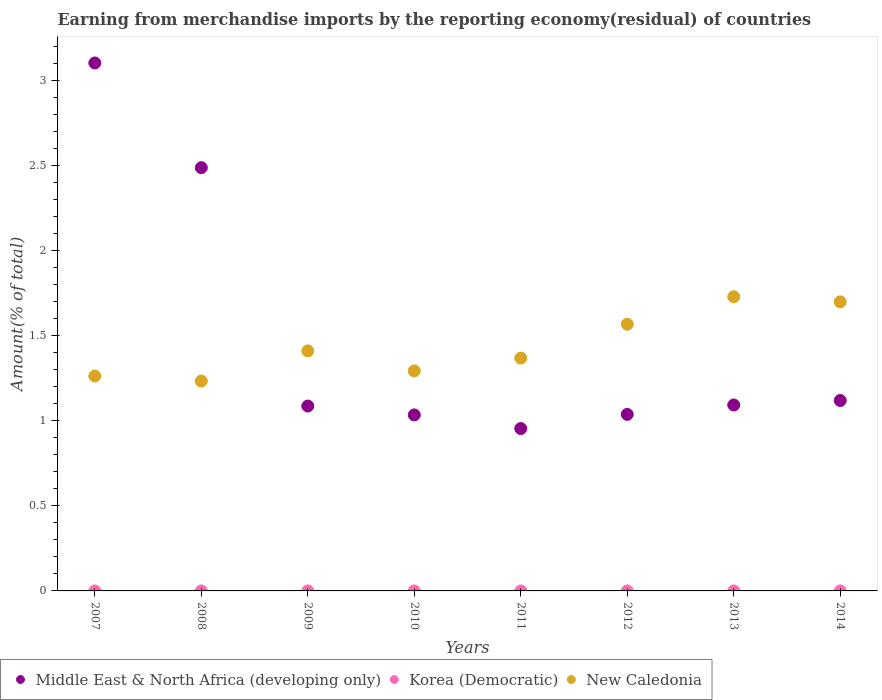Is the number of dotlines equal to the number of legend labels?
Provide a short and direct response. No. What is the percentage of amount earned from merchandise imports in Middle East & North Africa (developing only) in 2011?
Your answer should be compact. 0.95. Across all years, what is the maximum percentage of amount earned from merchandise imports in Middle East & North Africa (developing only)?
Your answer should be compact. 3.1. Across all years, what is the minimum percentage of amount earned from merchandise imports in Middle East & North Africa (developing only)?
Offer a terse response. 0.95. What is the total percentage of amount earned from merchandise imports in Middle East & North Africa (developing only) in the graph?
Your answer should be compact. 11.91. What is the difference between the percentage of amount earned from merchandise imports in New Caledonia in 2007 and that in 2010?
Ensure brevity in your answer.  -0.03. What is the difference between the percentage of amount earned from merchandise imports in New Caledonia in 2013 and the percentage of amount earned from merchandise imports in Korea (Democratic) in 2012?
Keep it short and to the point. 1.73. What is the average percentage of amount earned from merchandise imports in Korea (Democratic) per year?
Ensure brevity in your answer.  2.008655080248045e-9. In the year 2009, what is the difference between the percentage of amount earned from merchandise imports in New Caledonia and percentage of amount earned from merchandise imports in Korea (Democratic)?
Offer a very short reply. 1.41. What is the ratio of the percentage of amount earned from merchandise imports in New Caledonia in 2008 to that in 2010?
Keep it short and to the point. 0.95. Is the percentage of amount earned from merchandise imports in New Caledonia in 2007 less than that in 2014?
Offer a very short reply. Yes. Is the difference between the percentage of amount earned from merchandise imports in New Caledonia in 2011 and 2013 greater than the difference between the percentage of amount earned from merchandise imports in Korea (Democratic) in 2011 and 2013?
Ensure brevity in your answer.  No. What is the difference between the highest and the second highest percentage of amount earned from merchandise imports in New Caledonia?
Offer a very short reply. 0.03. What is the difference between the highest and the lowest percentage of amount earned from merchandise imports in Middle East & North Africa (developing only)?
Provide a succinct answer. 2.15. Is the sum of the percentage of amount earned from merchandise imports in Middle East & North Africa (developing only) in 2008 and 2010 greater than the maximum percentage of amount earned from merchandise imports in Korea (Democratic) across all years?
Provide a short and direct response. Yes. Does the percentage of amount earned from merchandise imports in New Caledonia monotonically increase over the years?
Ensure brevity in your answer.  No. What is the difference between two consecutive major ticks on the Y-axis?
Offer a very short reply. 0.5. Are the values on the major ticks of Y-axis written in scientific E-notation?
Offer a very short reply. No. Does the graph contain any zero values?
Offer a very short reply. Yes. Does the graph contain grids?
Give a very brief answer. No. Where does the legend appear in the graph?
Keep it short and to the point. Bottom left. How are the legend labels stacked?
Offer a terse response. Horizontal. What is the title of the graph?
Make the answer very short. Earning from merchandise imports by the reporting economy(residual) of countries. Does "Hong Kong" appear as one of the legend labels in the graph?
Make the answer very short. No. What is the label or title of the X-axis?
Make the answer very short. Years. What is the label or title of the Y-axis?
Give a very brief answer. Amount(% of total). What is the Amount(% of total) of Middle East & North Africa (developing only) in 2007?
Your answer should be very brief. 3.1. What is the Amount(% of total) in New Caledonia in 2007?
Provide a short and direct response. 1.26. What is the Amount(% of total) in Middle East & North Africa (developing only) in 2008?
Give a very brief answer. 2.49. What is the Amount(% of total) in Korea (Democratic) in 2008?
Ensure brevity in your answer.  0. What is the Amount(% of total) of New Caledonia in 2008?
Give a very brief answer. 1.23. What is the Amount(% of total) of Middle East & North Africa (developing only) in 2009?
Keep it short and to the point. 1.09. What is the Amount(% of total) of Korea (Democratic) in 2009?
Ensure brevity in your answer.  1.52340312053516e-9. What is the Amount(% of total) of New Caledonia in 2009?
Provide a succinct answer. 1.41. What is the Amount(% of total) in Middle East & North Africa (developing only) in 2010?
Your answer should be very brief. 1.03. What is the Amount(% of total) in New Caledonia in 2010?
Make the answer very short. 1.29. What is the Amount(% of total) in Middle East & North Africa (developing only) in 2011?
Keep it short and to the point. 0.95. What is the Amount(% of total) of Korea (Democratic) in 2011?
Provide a succinct answer. 5.979273196495129e-9. What is the Amount(% of total) of New Caledonia in 2011?
Make the answer very short. 1.37. What is the Amount(% of total) of Middle East & North Africa (developing only) in 2012?
Offer a very short reply. 1.04. What is the Amount(% of total) of Korea (Democratic) in 2012?
Give a very brief answer. 3.666766615126721e-9. What is the Amount(% of total) of New Caledonia in 2012?
Make the answer very short. 1.57. What is the Amount(% of total) in Middle East & North Africa (developing only) in 2013?
Provide a short and direct response. 1.09. What is the Amount(% of total) in Korea (Democratic) in 2013?
Your response must be concise. 4.89979770982735e-9. What is the Amount(% of total) of New Caledonia in 2013?
Keep it short and to the point. 1.73. What is the Amount(% of total) of Middle East & North Africa (developing only) in 2014?
Offer a very short reply. 1.12. What is the Amount(% of total) of New Caledonia in 2014?
Your response must be concise. 1.7. Across all years, what is the maximum Amount(% of total) in Middle East & North Africa (developing only)?
Your response must be concise. 3.1. Across all years, what is the maximum Amount(% of total) in Korea (Democratic)?
Provide a succinct answer. 5.979273196495129e-9. Across all years, what is the maximum Amount(% of total) of New Caledonia?
Offer a terse response. 1.73. Across all years, what is the minimum Amount(% of total) in Middle East & North Africa (developing only)?
Offer a very short reply. 0.95. Across all years, what is the minimum Amount(% of total) in New Caledonia?
Your response must be concise. 1.23. What is the total Amount(% of total) in Middle East & North Africa (developing only) in the graph?
Keep it short and to the point. 11.91. What is the total Amount(% of total) in Korea (Democratic) in the graph?
Your answer should be compact. 0. What is the total Amount(% of total) in New Caledonia in the graph?
Your answer should be very brief. 11.56. What is the difference between the Amount(% of total) of Middle East & North Africa (developing only) in 2007 and that in 2008?
Make the answer very short. 0.62. What is the difference between the Amount(% of total) in New Caledonia in 2007 and that in 2008?
Ensure brevity in your answer.  0.03. What is the difference between the Amount(% of total) in Middle East & North Africa (developing only) in 2007 and that in 2009?
Offer a terse response. 2.02. What is the difference between the Amount(% of total) of New Caledonia in 2007 and that in 2009?
Ensure brevity in your answer.  -0.15. What is the difference between the Amount(% of total) in Middle East & North Africa (developing only) in 2007 and that in 2010?
Give a very brief answer. 2.07. What is the difference between the Amount(% of total) of New Caledonia in 2007 and that in 2010?
Provide a short and direct response. -0.03. What is the difference between the Amount(% of total) of Middle East & North Africa (developing only) in 2007 and that in 2011?
Provide a succinct answer. 2.15. What is the difference between the Amount(% of total) in New Caledonia in 2007 and that in 2011?
Provide a short and direct response. -0.11. What is the difference between the Amount(% of total) in Middle East & North Africa (developing only) in 2007 and that in 2012?
Your answer should be very brief. 2.06. What is the difference between the Amount(% of total) in New Caledonia in 2007 and that in 2012?
Give a very brief answer. -0.3. What is the difference between the Amount(% of total) of Middle East & North Africa (developing only) in 2007 and that in 2013?
Provide a short and direct response. 2.01. What is the difference between the Amount(% of total) of New Caledonia in 2007 and that in 2013?
Ensure brevity in your answer.  -0.47. What is the difference between the Amount(% of total) in Middle East & North Africa (developing only) in 2007 and that in 2014?
Your answer should be compact. 1.98. What is the difference between the Amount(% of total) of New Caledonia in 2007 and that in 2014?
Provide a short and direct response. -0.44. What is the difference between the Amount(% of total) in Middle East & North Africa (developing only) in 2008 and that in 2009?
Provide a succinct answer. 1.4. What is the difference between the Amount(% of total) in New Caledonia in 2008 and that in 2009?
Offer a terse response. -0.18. What is the difference between the Amount(% of total) of Middle East & North Africa (developing only) in 2008 and that in 2010?
Offer a very short reply. 1.45. What is the difference between the Amount(% of total) in New Caledonia in 2008 and that in 2010?
Your answer should be compact. -0.06. What is the difference between the Amount(% of total) in Middle East & North Africa (developing only) in 2008 and that in 2011?
Your response must be concise. 1.53. What is the difference between the Amount(% of total) of New Caledonia in 2008 and that in 2011?
Your answer should be compact. -0.13. What is the difference between the Amount(% of total) of Middle East & North Africa (developing only) in 2008 and that in 2012?
Give a very brief answer. 1.45. What is the difference between the Amount(% of total) of New Caledonia in 2008 and that in 2012?
Provide a succinct answer. -0.33. What is the difference between the Amount(% of total) of Middle East & North Africa (developing only) in 2008 and that in 2013?
Offer a very short reply. 1.39. What is the difference between the Amount(% of total) of New Caledonia in 2008 and that in 2013?
Keep it short and to the point. -0.5. What is the difference between the Amount(% of total) of Middle East & North Africa (developing only) in 2008 and that in 2014?
Give a very brief answer. 1.37. What is the difference between the Amount(% of total) in New Caledonia in 2008 and that in 2014?
Keep it short and to the point. -0.47. What is the difference between the Amount(% of total) of Middle East & North Africa (developing only) in 2009 and that in 2010?
Offer a very short reply. 0.05. What is the difference between the Amount(% of total) of New Caledonia in 2009 and that in 2010?
Offer a very short reply. 0.12. What is the difference between the Amount(% of total) of Middle East & North Africa (developing only) in 2009 and that in 2011?
Provide a short and direct response. 0.13. What is the difference between the Amount(% of total) in Korea (Democratic) in 2009 and that in 2011?
Offer a very short reply. -0. What is the difference between the Amount(% of total) of New Caledonia in 2009 and that in 2011?
Provide a succinct answer. 0.04. What is the difference between the Amount(% of total) in Middle East & North Africa (developing only) in 2009 and that in 2012?
Offer a very short reply. 0.05. What is the difference between the Amount(% of total) of Korea (Democratic) in 2009 and that in 2012?
Your answer should be compact. -0. What is the difference between the Amount(% of total) in New Caledonia in 2009 and that in 2012?
Your answer should be compact. -0.16. What is the difference between the Amount(% of total) in Middle East & North Africa (developing only) in 2009 and that in 2013?
Keep it short and to the point. -0.01. What is the difference between the Amount(% of total) of New Caledonia in 2009 and that in 2013?
Ensure brevity in your answer.  -0.32. What is the difference between the Amount(% of total) in Middle East & North Africa (developing only) in 2009 and that in 2014?
Give a very brief answer. -0.03. What is the difference between the Amount(% of total) of New Caledonia in 2009 and that in 2014?
Provide a succinct answer. -0.29. What is the difference between the Amount(% of total) in Middle East & North Africa (developing only) in 2010 and that in 2011?
Provide a short and direct response. 0.08. What is the difference between the Amount(% of total) in New Caledonia in 2010 and that in 2011?
Provide a succinct answer. -0.08. What is the difference between the Amount(% of total) of Middle East & North Africa (developing only) in 2010 and that in 2012?
Provide a short and direct response. -0. What is the difference between the Amount(% of total) in New Caledonia in 2010 and that in 2012?
Ensure brevity in your answer.  -0.27. What is the difference between the Amount(% of total) of Middle East & North Africa (developing only) in 2010 and that in 2013?
Your answer should be very brief. -0.06. What is the difference between the Amount(% of total) of New Caledonia in 2010 and that in 2013?
Your answer should be very brief. -0.44. What is the difference between the Amount(% of total) of Middle East & North Africa (developing only) in 2010 and that in 2014?
Provide a short and direct response. -0.08. What is the difference between the Amount(% of total) of New Caledonia in 2010 and that in 2014?
Offer a terse response. -0.41. What is the difference between the Amount(% of total) of Middle East & North Africa (developing only) in 2011 and that in 2012?
Make the answer very short. -0.08. What is the difference between the Amount(% of total) of New Caledonia in 2011 and that in 2012?
Provide a succinct answer. -0.2. What is the difference between the Amount(% of total) in Middle East & North Africa (developing only) in 2011 and that in 2013?
Offer a terse response. -0.14. What is the difference between the Amount(% of total) in New Caledonia in 2011 and that in 2013?
Give a very brief answer. -0.36. What is the difference between the Amount(% of total) of Middle East & North Africa (developing only) in 2011 and that in 2014?
Your response must be concise. -0.16. What is the difference between the Amount(% of total) of New Caledonia in 2011 and that in 2014?
Ensure brevity in your answer.  -0.33. What is the difference between the Amount(% of total) in Middle East & North Africa (developing only) in 2012 and that in 2013?
Keep it short and to the point. -0.06. What is the difference between the Amount(% of total) in Korea (Democratic) in 2012 and that in 2013?
Your response must be concise. -0. What is the difference between the Amount(% of total) in New Caledonia in 2012 and that in 2013?
Provide a succinct answer. -0.16. What is the difference between the Amount(% of total) in Middle East & North Africa (developing only) in 2012 and that in 2014?
Keep it short and to the point. -0.08. What is the difference between the Amount(% of total) in New Caledonia in 2012 and that in 2014?
Keep it short and to the point. -0.13. What is the difference between the Amount(% of total) of Middle East & North Africa (developing only) in 2013 and that in 2014?
Make the answer very short. -0.03. What is the difference between the Amount(% of total) of New Caledonia in 2013 and that in 2014?
Make the answer very short. 0.03. What is the difference between the Amount(% of total) in Middle East & North Africa (developing only) in 2007 and the Amount(% of total) in New Caledonia in 2008?
Make the answer very short. 1.87. What is the difference between the Amount(% of total) in Middle East & North Africa (developing only) in 2007 and the Amount(% of total) in Korea (Democratic) in 2009?
Offer a terse response. 3.1. What is the difference between the Amount(% of total) in Middle East & North Africa (developing only) in 2007 and the Amount(% of total) in New Caledonia in 2009?
Keep it short and to the point. 1.69. What is the difference between the Amount(% of total) of Middle East & North Africa (developing only) in 2007 and the Amount(% of total) of New Caledonia in 2010?
Offer a very short reply. 1.81. What is the difference between the Amount(% of total) in Middle East & North Africa (developing only) in 2007 and the Amount(% of total) in Korea (Democratic) in 2011?
Offer a terse response. 3.1. What is the difference between the Amount(% of total) in Middle East & North Africa (developing only) in 2007 and the Amount(% of total) in New Caledonia in 2011?
Provide a succinct answer. 1.73. What is the difference between the Amount(% of total) of Middle East & North Africa (developing only) in 2007 and the Amount(% of total) of Korea (Democratic) in 2012?
Make the answer very short. 3.1. What is the difference between the Amount(% of total) of Middle East & North Africa (developing only) in 2007 and the Amount(% of total) of New Caledonia in 2012?
Make the answer very short. 1.54. What is the difference between the Amount(% of total) in Middle East & North Africa (developing only) in 2007 and the Amount(% of total) in Korea (Democratic) in 2013?
Your answer should be compact. 3.1. What is the difference between the Amount(% of total) of Middle East & North Africa (developing only) in 2007 and the Amount(% of total) of New Caledonia in 2013?
Your response must be concise. 1.37. What is the difference between the Amount(% of total) in Middle East & North Africa (developing only) in 2007 and the Amount(% of total) in New Caledonia in 2014?
Offer a very short reply. 1.4. What is the difference between the Amount(% of total) of Middle East & North Africa (developing only) in 2008 and the Amount(% of total) of Korea (Democratic) in 2009?
Ensure brevity in your answer.  2.49. What is the difference between the Amount(% of total) of Middle East & North Africa (developing only) in 2008 and the Amount(% of total) of New Caledonia in 2009?
Provide a short and direct response. 1.08. What is the difference between the Amount(% of total) of Middle East & North Africa (developing only) in 2008 and the Amount(% of total) of New Caledonia in 2010?
Give a very brief answer. 1.19. What is the difference between the Amount(% of total) of Middle East & North Africa (developing only) in 2008 and the Amount(% of total) of Korea (Democratic) in 2011?
Provide a short and direct response. 2.49. What is the difference between the Amount(% of total) of Middle East & North Africa (developing only) in 2008 and the Amount(% of total) of New Caledonia in 2011?
Ensure brevity in your answer.  1.12. What is the difference between the Amount(% of total) in Middle East & North Africa (developing only) in 2008 and the Amount(% of total) in Korea (Democratic) in 2012?
Provide a short and direct response. 2.49. What is the difference between the Amount(% of total) in Middle East & North Africa (developing only) in 2008 and the Amount(% of total) in New Caledonia in 2012?
Provide a succinct answer. 0.92. What is the difference between the Amount(% of total) in Middle East & North Africa (developing only) in 2008 and the Amount(% of total) in Korea (Democratic) in 2013?
Provide a succinct answer. 2.49. What is the difference between the Amount(% of total) in Middle East & North Africa (developing only) in 2008 and the Amount(% of total) in New Caledonia in 2013?
Make the answer very short. 0.76. What is the difference between the Amount(% of total) of Middle East & North Africa (developing only) in 2008 and the Amount(% of total) of New Caledonia in 2014?
Make the answer very short. 0.79. What is the difference between the Amount(% of total) of Middle East & North Africa (developing only) in 2009 and the Amount(% of total) of New Caledonia in 2010?
Offer a terse response. -0.21. What is the difference between the Amount(% of total) in Korea (Democratic) in 2009 and the Amount(% of total) in New Caledonia in 2010?
Offer a very short reply. -1.29. What is the difference between the Amount(% of total) of Middle East & North Africa (developing only) in 2009 and the Amount(% of total) of Korea (Democratic) in 2011?
Make the answer very short. 1.09. What is the difference between the Amount(% of total) of Middle East & North Africa (developing only) in 2009 and the Amount(% of total) of New Caledonia in 2011?
Keep it short and to the point. -0.28. What is the difference between the Amount(% of total) of Korea (Democratic) in 2009 and the Amount(% of total) of New Caledonia in 2011?
Provide a short and direct response. -1.37. What is the difference between the Amount(% of total) in Middle East & North Africa (developing only) in 2009 and the Amount(% of total) in Korea (Democratic) in 2012?
Offer a terse response. 1.09. What is the difference between the Amount(% of total) of Middle East & North Africa (developing only) in 2009 and the Amount(% of total) of New Caledonia in 2012?
Offer a terse response. -0.48. What is the difference between the Amount(% of total) of Korea (Democratic) in 2009 and the Amount(% of total) of New Caledonia in 2012?
Make the answer very short. -1.57. What is the difference between the Amount(% of total) of Middle East & North Africa (developing only) in 2009 and the Amount(% of total) of Korea (Democratic) in 2013?
Provide a succinct answer. 1.09. What is the difference between the Amount(% of total) of Middle East & North Africa (developing only) in 2009 and the Amount(% of total) of New Caledonia in 2013?
Make the answer very short. -0.64. What is the difference between the Amount(% of total) of Korea (Democratic) in 2009 and the Amount(% of total) of New Caledonia in 2013?
Provide a succinct answer. -1.73. What is the difference between the Amount(% of total) of Middle East & North Africa (developing only) in 2009 and the Amount(% of total) of New Caledonia in 2014?
Offer a very short reply. -0.61. What is the difference between the Amount(% of total) in Korea (Democratic) in 2009 and the Amount(% of total) in New Caledonia in 2014?
Offer a terse response. -1.7. What is the difference between the Amount(% of total) of Middle East & North Africa (developing only) in 2010 and the Amount(% of total) of Korea (Democratic) in 2011?
Offer a terse response. 1.03. What is the difference between the Amount(% of total) of Middle East & North Africa (developing only) in 2010 and the Amount(% of total) of New Caledonia in 2011?
Keep it short and to the point. -0.33. What is the difference between the Amount(% of total) in Middle East & North Africa (developing only) in 2010 and the Amount(% of total) in Korea (Democratic) in 2012?
Ensure brevity in your answer.  1.03. What is the difference between the Amount(% of total) in Middle East & North Africa (developing only) in 2010 and the Amount(% of total) in New Caledonia in 2012?
Ensure brevity in your answer.  -0.53. What is the difference between the Amount(% of total) in Middle East & North Africa (developing only) in 2010 and the Amount(% of total) in Korea (Democratic) in 2013?
Offer a very short reply. 1.03. What is the difference between the Amount(% of total) in Middle East & North Africa (developing only) in 2010 and the Amount(% of total) in New Caledonia in 2013?
Provide a short and direct response. -0.69. What is the difference between the Amount(% of total) in Middle East & North Africa (developing only) in 2010 and the Amount(% of total) in New Caledonia in 2014?
Keep it short and to the point. -0.66. What is the difference between the Amount(% of total) of Middle East & North Africa (developing only) in 2011 and the Amount(% of total) of Korea (Democratic) in 2012?
Give a very brief answer. 0.95. What is the difference between the Amount(% of total) of Middle East & North Africa (developing only) in 2011 and the Amount(% of total) of New Caledonia in 2012?
Keep it short and to the point. -0.61. What is the difference between the Amount(% of total) in Korea (Democratic) in 2011 and the Amount(% of total) in New Caledonia in 2012?
Provide a succinct answer. -1.57. What is the difference between the Amount(% of total) of Middle East & North Africa (developing only) in 2011 and the Amount(% of total) of Korea (Democratic) in 2013?
Ensure brevity in your answer.  0.95. What is the difference between the Amount(% of total) in Middle East & North Africa (developing only) in 2011 and the Amount(% of total) in New Caledonia in 2013?
Offer a very short reply. -0.77. What is the difference between the Amount(% of total) of Korea (Democratic) in 2011 and the Amount(% of total) of New Caledonia in 2013?
Make the answer very short. -1.73. What is the difference between the Amount(% of total) in Middle East & North Africa (developing only) in 2011 and the Amount(% of total) in New Caledonia in 2014?
Make the answer very short. -0.74. What is the difference between the Amount(% of total) in Korea (Democratic) in 2011 and the Amount(% of total) in New Caledonia in 2014?
Your response must be concise. -1.7. What is the difference between the Amount(% of total) of Middle East & North Africa (developing only) in 2012 and the Amount(% of total) of Korea (Democratic) in 2013?
Your answer should be compact. 1.04. What is the difference between the Amount(% of total) of Middle East & North Africa (developing only) in 2012 and the Amount(% of total) of New Caledonia in 2013?
Make the answer very short. -0.69. What is the difference between the Amount(% of total) in Korea (Democratic) in 2012 and the Amount(% of total) in New Caledonia in 2013?
Your response must be concise. -1.73. What is the difference between the Amount(% of total) of Middle East & North Africa (developing only) in 2012 and the Amount(% of total) of New Caledonia in 2014?
Offer a terse response. -0.66. What is the difference between the Amount(% of total) in Korea (Democratic) in 2012 and the Amount(% of total) in New Caledonia in 2014?
Provide a succinct answer. -1.7. What is the difference between the Amount(% of total) in Middle East & North Africa (developing only) in 2013 and the Amount(% of total) in New Caledonia in 2014?
Give a very brief answer. -0.61. What is the difference between the Amount(% of total) in Korea (Democratic) in 2013 and the Amount(% of total) in New Caledonia in 2014?
Provide a short and direct response. -1.7. What is the average Amount(% of total) of Middle East & North Africa (developing only) per year?
Provide a short and direct response. 1.49. What is the average Amount(% of total) of Korea (Democratic) per year?
Offer a terse response. 0. What is the average Amount(% of total) in New Caledonia per year?
Your answer should be compact. 1.45. In the year 2007, what is the difference between the Amount(% of total) in Middle East & North Africa (developing only) and Amount(% of total) in New Caledonia?
Provide a short and direct response. 1.84. In the year 2008, what is the difference between the Amount(% of total) of Middle East & North Africa (developing only) and Amount(% of total) of New Caledonia?
Provide a succinct answer. 1.25. In the year 2009, what is the difference between the Amount(% of total) in Middle East & North Africa (developing only) and Amount(% of total) in Korea (Democratic)?
Your answer should be very brief. 1.09. In the year 2009, what is the difference between the Amount(% of total) in Middle East & North Africa (developing only) and Amount(% of total) in New Caledonia?
Ensure brevity in your answer.  -0.32. In the year 2009, what is the difference between the Amount(% of total) of Korea (Democratic) and Amount(% of total) of New Caledonia?
Offer a very short reply. -1.41. In the year 2010, what is the difference between the Amount(% of total) in Middle East & North Africa (developing only) and Amount(% of total) in New Caledonia?
Your response must be concise. -0.26. In the year 2011, what is the difference between the Amount(% of total) in Middle East & North Africa (developing only) and Amount(% of total) in Korea (Democratic)?
Your answer should be very brief. 0.95. In the year 2011, what is the difference between the Amount(% of total) in Middle East & North Africa (developing only) and Amount(% of total) in New Caledonia?
Your answer should be very brief. -0.41. In the year 2011, what is the difference between the Amount(% of total) of Korea (Democratic) and Amount(% of total) of New Caledonia?
Keep it short and to the point. -1.37. In the year 2012, what is the difference between the Amount(% of total) of Middle East & North Africa (developing only) and Amount(% of total) of Korea (Democratic)?
Offer a very short reply. 1.04. In the year 2012, what is the difference between the Amount(% of total) in Middle East & North Africa (developing only) and Amount(% of total) in New Caledonia?
Your answer should be compact. -0.53. In the year 2012, what is the difference between the Amount(% of total) in Korea (Democratic) and Amount(% of total) in New Caledonia?
Make the answer very short. -1.57. In the year 2013, what is the difference between the Amount(% of total) in Middle East & North Africa (developing only) and Amount(% of total) in Korea (Democratic)?
Provide a short and direct response. 1.09. In the year 2013, what is the difference between the Amount(% of total) in Middle East & North Africa (developing only) and Amount(% of total) in New Caledonia?
Offer a terse response. -0.64. In the year 2013, what is the difference between the Amount(% of total) of Korea (Democratic) and Amount(% of total) of New Caledonia?
Provide a succinct answer. -1.73. In the year 2014, what is the difference between the Amount(% of total) in Middle East & North Africa (developing only) and Amount(% of total) in New Caledonia?
Keep it short and to the point. -0.58. What is the ratio of the Amount(% of total) of Middle East & North Africa (developing only) in 2007 to that in 2008?
Keep it short and to the point. 1.25. What is the ratio of the Amount(% of total) of New Caledonia in 2007 to that in 2008?
Keep it short and to the point. 1.02. What is the ratio of the Amount(% of total) in Middle East & North Africa (developing only) in 2007 to that in 2009?
Make the answer very short. 2.86. What is the ratio of the Amount(% of total) in New Caledonia in 2007 to that in 2009?
Your answer should be very brief. 0.9. What is the ratio of the Amount(% of total) of Middle East & North Africa (developing only) in 2007 to that in 2010?
Your answer should be compact. 3. What is the ratio of the Amount(% of total) of New Caledonia in 2007 to that in 2010?
Your answer should be very brief. 0.98. What is the ratio of the Amount(% of total) of Middle East & North Africa (developing only) in 2007 to that in 2011?
Your response must be concise. 3.25. What is the ratio of the Amount(% of total) of New Caledonia in 2007 to that in 2011?
Offer a terse response. 0.92. What is the ratio of the Amount(% of total) in Middle East & North Africa (developing only) in 2007 to that in 2012?
Keep it short and to the point. 2.99. What is the ratio of the Amount(% of total) of New Caledonia in 2007 to that in 2012?
Give a very brief answer. 0.81. What is the ratio of the Amount(% of total) in Middle East & North Africa (developing only) in 2007 to that in 2013?
Make the answer very short. 2.84. What is the ratio of the Amount(% of total) in New Caledonia in 2007 to that in 2013?
Give a very brief answer. 0.73. What is the ratio of the Amount(% of total) in Middle East & North Africa (developing only) in 2007 to that in 2014?
Provide a short and direct response. 2.77. What is the ratio of the Amount(% of total) in New Caledonia in 2007 to that in 2014?
Give a very brief answer. 0.74. What is the ratio of the Amount(% of total) in Middle East & North Africa (developing only) in 2008 to that in 2009?
Give a very brief answer. 2.29. What is the ratio of the Amount(% of total) in New Caledonia in 2008 to that in 2009?
Offer a very short reply. 0.87. What is the ratio of the Amount(% of total) of Middle East & North Africa (developing only) in 2008 to that in 2010?
Your answer should be compact. 2.4. What is the ratio of the Amount(% of total) in New Caledonia in 2008 to that in 2010?
Your answer should be compact. 0.95. What is the ratio of the Amount(% of total) of Middle East & North Africa (developing only) in 2008 to that in 2011?
Offer a terse response. 2.61. What is the ratio of the Amount(% of total) in New Caledonia in 2008 to that in 2011?
Your answer should be very brief. 0.9. What is the ratio of the Amount(% of total) in Middle East & North Africa (developing only) in 2008 to that in 2012?
Keep it short and to the point. 2.4. What is the ratio of the Amount(% of total) in New Caledonia in 2008 to that in 2012?
Your response must be concise. 0.79. What is the ratio of the Amount(% of total) of Middle East & North Africa (developing only) in 2008 to that in 2013?
Keep it short and to the point. 2.28. What is the ratio of the Amount(% of total) in New Caledonia in 2008 to that in 2013?
Provide a succinct answer. 0.71. What is the ratio of the Amount(% of total) of Middle East & North Africa (developing only) in 2008 to that in 2014?
Provide a succinct answer. 2.22. What is the ratio of the Amount(% of total) of New Caledonia in 2008 to that in 2014?
Provide a short and direct response. 0.73. What is the ratio of the Amount(% of total) in Middle East & North Africa (developing only) in 2009 to that in 2010?
Keep it short and to the point. 1.05. What is the ratio of the Amount(% of total) in New Caledonia in 2009 to that in 2010?
Make the answer very short. 1.09. What is the ratio of the Amount(% of total) of Middle East & North Africa (developing only) in 2009 to that in 2011?
Make the answer very short. 1.14. What is the ratio of the Amount(% of total) of Korea (Democratic) in 2009 to that in 2011?
Keep it short and to the point. 0.25. What is the ratio of the Amount(% of total) of New Caledonia in 2009 to that in 2011?
Your answer should be very brief. 1.03. What is the ratio of the Amount(% of total) in Middle East & North Africa (developing only) in 2009 to that in 2012?
Give a very brief answer. 1.05. What is the ratio of the Amount(% of total) in Korea (Democratic) in 2009 to that in 2012?
Your answer should be very brief. 0.42. What is the ratio of the Amount(% of total) in New Caledonia in 2009 to that in 2012?
Your answer should be compact. 0.9. What is the ratio of the Amount(% of total) of Middle East & North Africa (developing only) in 2009 to that in 2013?
Your answer should be compact. 0.99. What is the ratio of the Amount(% of total) of Korea (Democratic) in 2009 to that in 2013?
Your answer should be compact. 0.31. What is the ratio of the Amount(% of total) of New Caledonia in 2009 to that in 2013?
Provide a short and direct response. 0.82. What is the ratio of the Amount(% of total) in Middle East & North Africa (developing only) in 2009 to that in 2014?
Ensure brevity in your answer.  0.97. What is the ratio of the Amount(% of total) in New Caledonia in 2009 to that in 2014?
Provide a succinct answer. 0.83. What is the ratio of the Amount(% of total) in Middle East & North Africa (developing only) in 2010 to that in 2011?
Provide a short and direct response. 1.08. What is the ratio of the Amount(% of total) in New Caledonia in 2010 to that in 2011?
Provide a succinct answer. 0.94. What is the ratio of the Amount(% of total) in Middle East & North Africa (developing only) in 2010 to that in 2012?
Provide a short and direct response. 1. What is the ratio of the Amount(% of total) of New Caledonia in 2010 to that in 2012?
Your answer should be compact. 0.82. What is the ratio of the Amount(% of total) of Middle East & North Africa (developing only) in 2010 to that in 2013?
Give a very brief answer. 0.95. What is the ratio of the Amount(% of total) of New Caledonia in 2010 to that in 2013?
Your answer should be compact. 0.75. What is the ratio of the Amount(% of total) in Middle East & North Africa (developing only) in 2010 to that in 2014?
Ensure brevity in your answer.  0.92. What is the ratio of the Amount(% of total) of New Caledonia in 2010 to that in 2014?
Offer a very short reply. 0.76. What is the ratio of the Amount(% of total) in Middle East & North Africa (developing only) in 2011 to that in 2012?
Your answer should be compact. 0.92. What is the ratio of the Amount(% of total) of Korea (Democratic) in 2011 to that in 2012?
Provide a succinct answer. 1.63. What is the ratio of the Amount(% of total) of New Caledonia in 2011 to that in 2012?
Offer a terse response. 0.87. What is the ratio of the Amount(% of total) in Middle East & North Africa (developing only) in 2011 to that in 2013?
Your answer should be very brief. 0.87. What is the ratio of the Amount(% of total) in Korea (Democratic) in 2011 to that in 2013?
Your answer should be compact. 1.22. What is the ratio of the Amount(% of total) of New Caledonia in 2011 to that in 2013?
Offer a very short reply. 0.79. What is the ratio of the Amount(% of total) in Middle East & North Africa (developing only) in 2011 to that in 2014?
Your response must be concise. 0.85. What is the ratio of the Amount(% of total) in New Caledonia in 2011 to that in 2014?
Ensure brevity in your answer.  0.81. What is the ratio of the Amount(% of total) in Middle East & North Africa (developing only) in 2012 to that in 2013?
Make the answer very short. 0.95. What is the ratio of the Amount(% of total) in Korea (Democratic) in 2012 to that in 2013?
Provide a short and direct response. 0.75. What is the ratio of the Amount(% of total) of New Caledonia in 2012 to that in 2013?
Provide a succinct answer. 0.91. What is the ratio of the Amount(% of total) of Middle East & North Africa (developing only) in 2012 to that in 2014?
Your answer should be compact. 0.93. What is the ratio of the Amount(% of total) of New Caledonia in 2012 to that in 2014?
Your response must be concise. 0.92. What is the ratio of the Amount(% of total) of Middle East & North Africa (developing only) in 2013 to that in 2014?
Keep it short and to the point. 0.98. What is the ratio of the Amount(% of total) in New Caledonia in 2013 to that in 2014?
Your answer should be very brief. 1.02. What is the difference between the highest and the second highest Amount(% of total) in Middle East & North Africa (developing only)?
Your answer should be compact. 0.62. What is the difference between the highest and the second highest Amount(% of total) in New Caledonia?
Your answer should be very brief. 0.03. What is the difference between the highest and the lowest Amount(% of total) in Middle East & North Africa (developing only)?
Keep it short and to the point. 2.15. What is the difference between the highest and the lowest Amount(% of total) of Korea (Democratic)?
Offer a very short reply. 0. What is the difference between the highest and the lowest Amount(% of total) in New Caledonia?
Your answer should be compact. 0.5. 